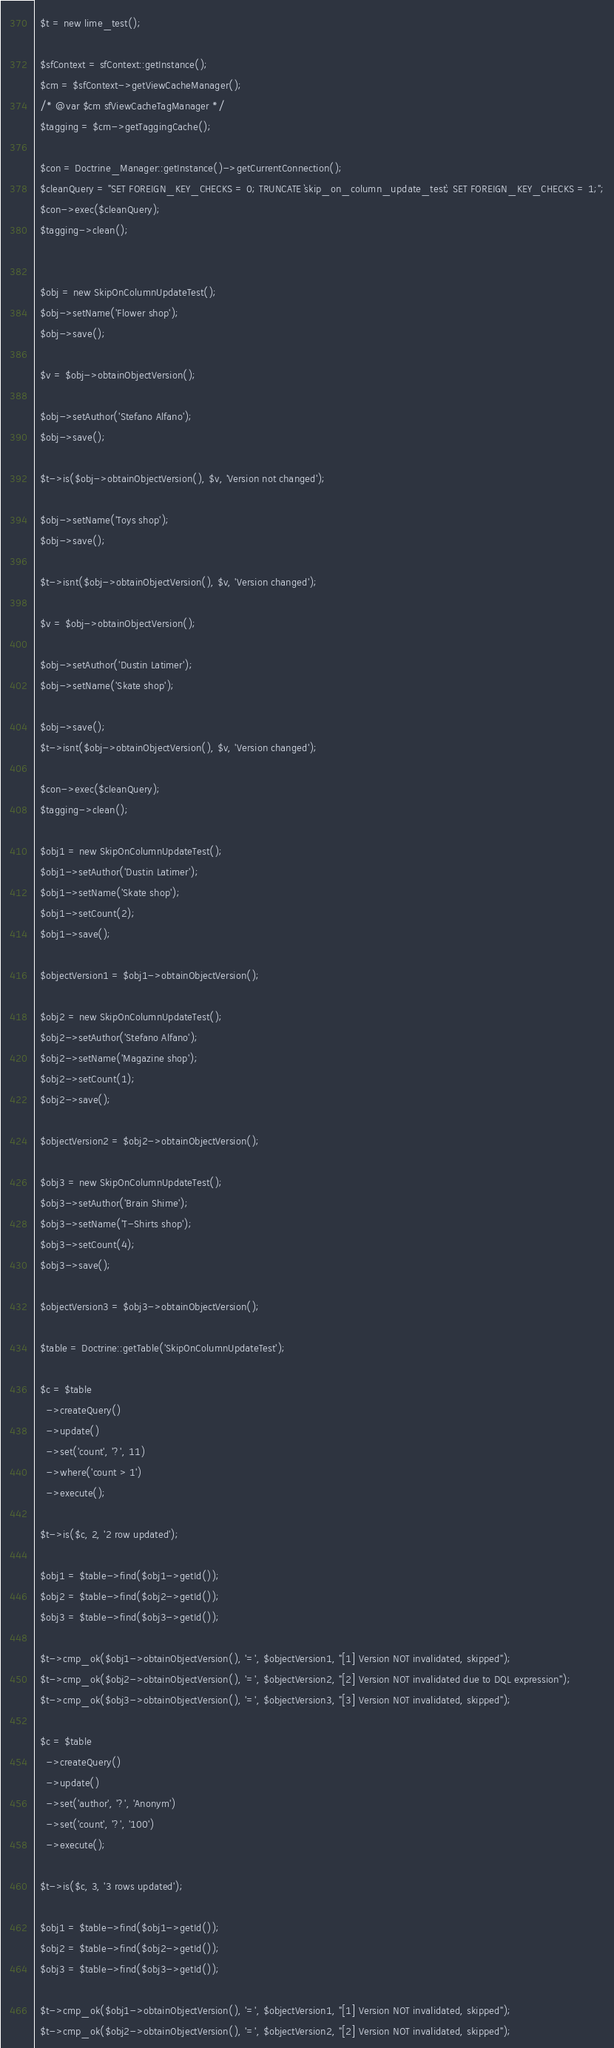Convert code to text. <code><loc_0><loc_0><loc_500><loc_500><_PHP_>  $t = new lime_test();

  $sfContext = sfContext::getInstance();
  $cm = $sfContext->getViewCacheManager();
  /* @var $cm sfViewCacheTagManager */
  $tagging = $cm->getTaggingCache();

  $con = Doctrine_Manager::getInstance()->getCurrentConnection();
  $cleanQuery = "SET FOREIGN_KEY_CHECKS = 0; TRUNCATE `skip_on_column_update_test`; SET FOREIGN_KEY_CHECKS = 1;";
  $con->exec($cleanQuery);
  $tagging->clean();


  $obj = new SkipOnColumnUpdateTest();
  $obj->setName('Flower shop');
  $obj->save();

  $v = $obj->obtainObjectVersion();

  $obj->setAuthor('Stefano Alfano');
  $obj->save();

  $t->is($obj->obtainObjectVersion(), $v, 'Version not changed');

  $obj->setName('Toys shop');
  $obj->save();

  $t->isnt($obj->obtainObjectVersion(), $v, 'Version changed');

  $v = $obj->obtainObjectVersion();

  $obj->setAuthor('Dustin Latimer');
  $obj->setName('Skate shop');

  $obj->save();
  $t->isnt($obj->obtainObjectVersion(), $v, 'Version changed');

  $con->exec($cleanQuery);
  $tagging->clean();

  $obj1 = new SkipOnColumnUpdateTest();
  $obj1->setAuthor('Dustin Latimer');
  $obj1->setName('Skate shop');
  $obj1->setCount(2);
  $obj1->save();

  $objectVersion1 = $obj1->obtainObjectVersion();

  $obj2 = new SkipOnColumnUpdateTest();
  $obj2->setAuthor('Stefano Alfano');
  $obj2->setName('Magazine shop');
  $obj2->setCount(1);
  $obj2->save();

  $objectVersion2 = $obj2->obtainObjectVersion();

  $obj3 = new SkipOnColumnUpdateTest();
  $obj3->setAuthor('Brain Shime');
  $obj3->setName('T-Shirts shop');
  $obj3->setCount(4);
  $obj3->save();

  $objectVersion3 = $obj3->obtainObjectVersion();

  $table = Doctrine::getTable('SkipOnColumnUpdateTest');

  $c = $table
    ->createQuery()
    ->update()
    ->set('count', '?', 11)
    ->where('count > 1')
    ->execute();

  $t->is($c, 2, '2 row updated');

  $obj1 = $table->find($obj1->getId());
  $obj2 = $table->find($obj2->getId());
  $obj3 = $table->find($obj3->getId());

  $t->cmp_ok($obj1->obtainObjectVersion(), '=', $objectVersion1, "[1] Version NOT invalidated, skipped");
  $t->cmp_ok($obj2->obtainObjectVersion(), '=', $objectVersion2, "[2] Version NOT invalidated due to DQL expression");
  $t->cmp_ok($obj3->obtainObjectVersion(), '=', $objectVersion3, "[3] Version NOT invalidated, skipped");

  $c = $table
    ->createQuery()
    ->update()
    ->set('author', '?', 'Anonym')
    ->set('count', '?', '100')
    ->execute();

  $t->is($c, 3, '3 rows updated');

  $obj1 = $table->find($obj1->getId());
  $obj2 = $table->find($obj2->getId());
  $obj3 = $table->find($obj3->getId());

  $t->cmp_ok($obj1->obtainObjectVersion(), '=', $objectVersion1, "[1] Version NOT invalidated, skipped");
  $t->cmp_ok($obj2->obtainObjectVersion(), '=', $objectVersion2, "[2] Version NOT invalidated, skipped");</code> 